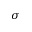Convert formula to latex. <formula><loc_0><loc_0><loc_500><loc_500>\sigma</formula> 